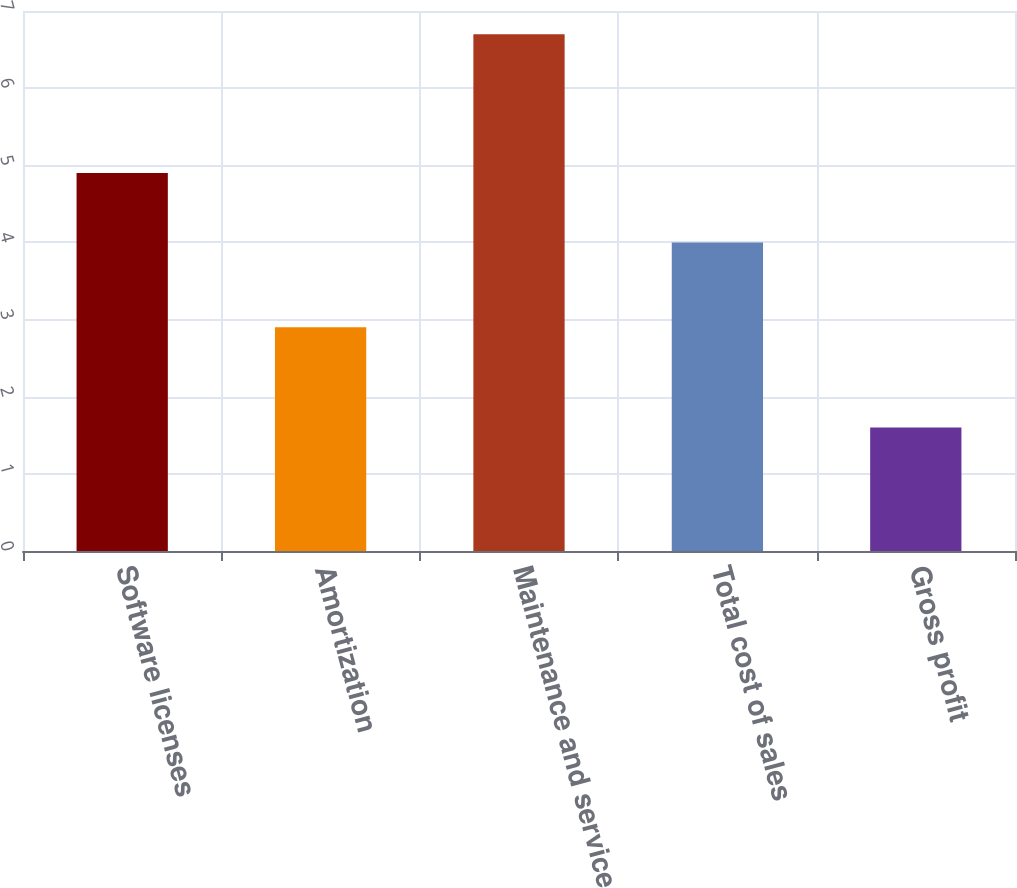<chart> <loc_0><loc_0><loc_500><loc_500><bar_chart><fcel>Software licenses<fcel>Amortization<fcel>Maintenance and service<fcel>Total cost of sales<fcel>Gross profit<nl><fcel>4.9<fcel>2.9<fcel>6.7<fcel>4<fcel>1.6<nl></chart> 